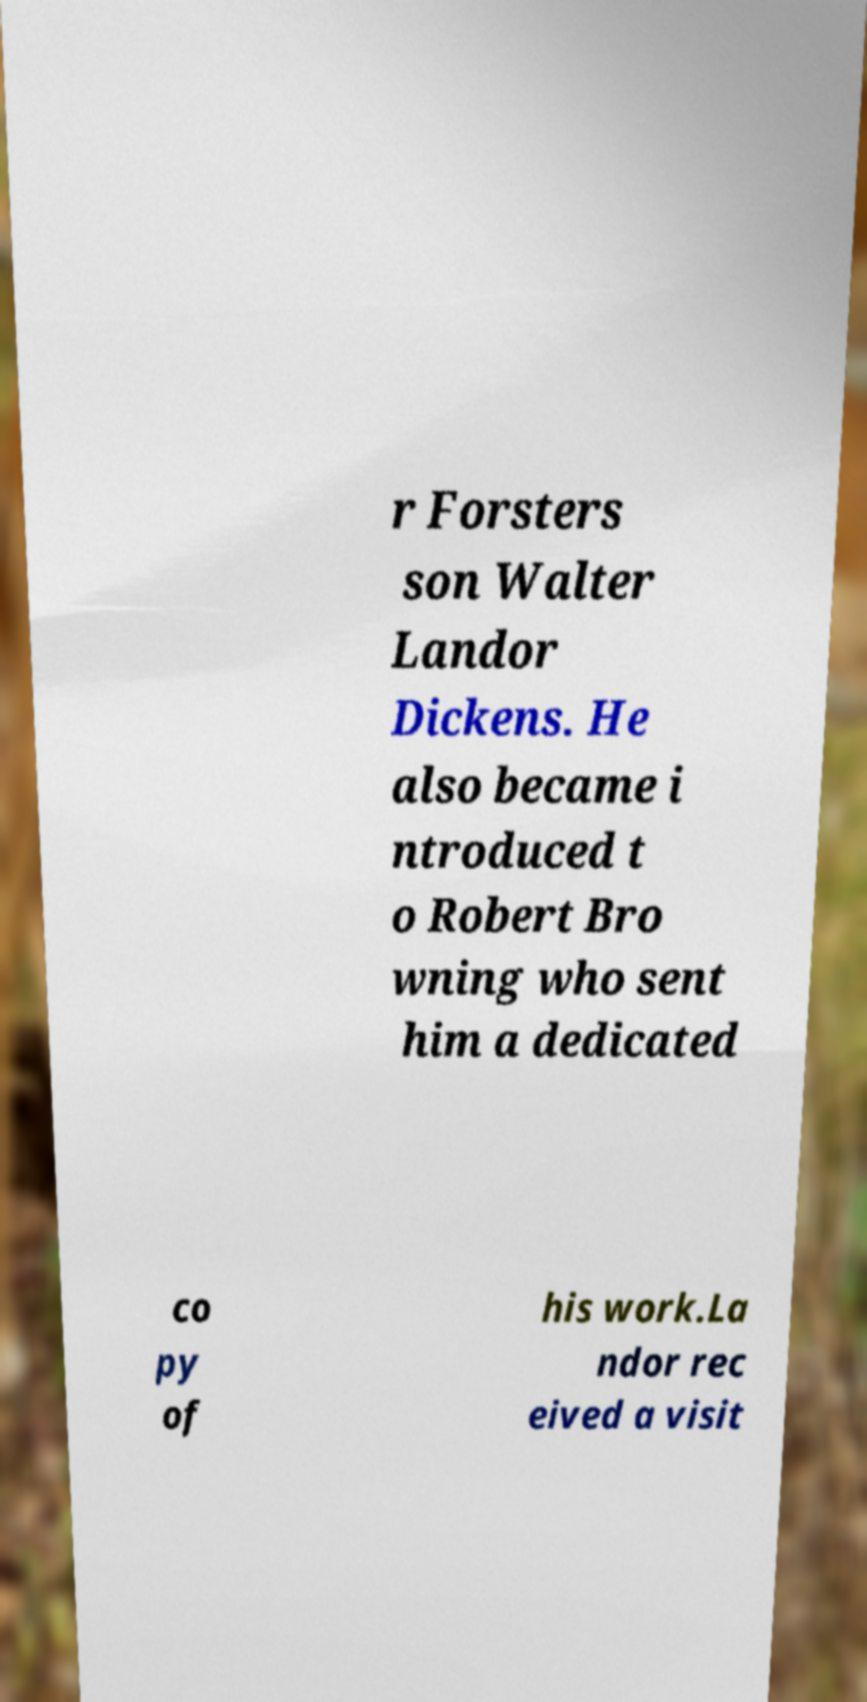Could you extract and type out the text from this image? r Forsters son Walter Landor Dickens. He also became i ntroduced t o Robert Bro wning who sent him a dedicated co py of his work.La ndor rec eived a visit 